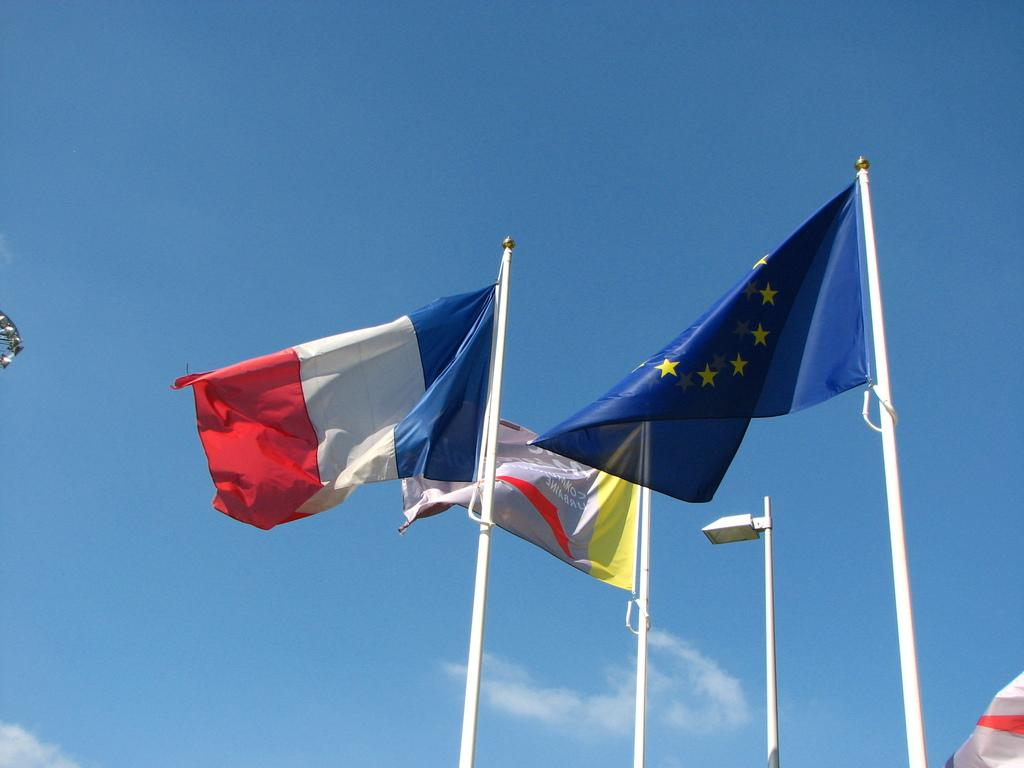What can be seen flying in the image? There are flags in the image. What are the flags attached to? The flags are attached to poles in the image. What can be seen in the background of the image? The sky is visible in the background of the image. What type of advertisement can be seen on the flags in the image? There is no advertisement present on the flags in the image; they are simply flying. 